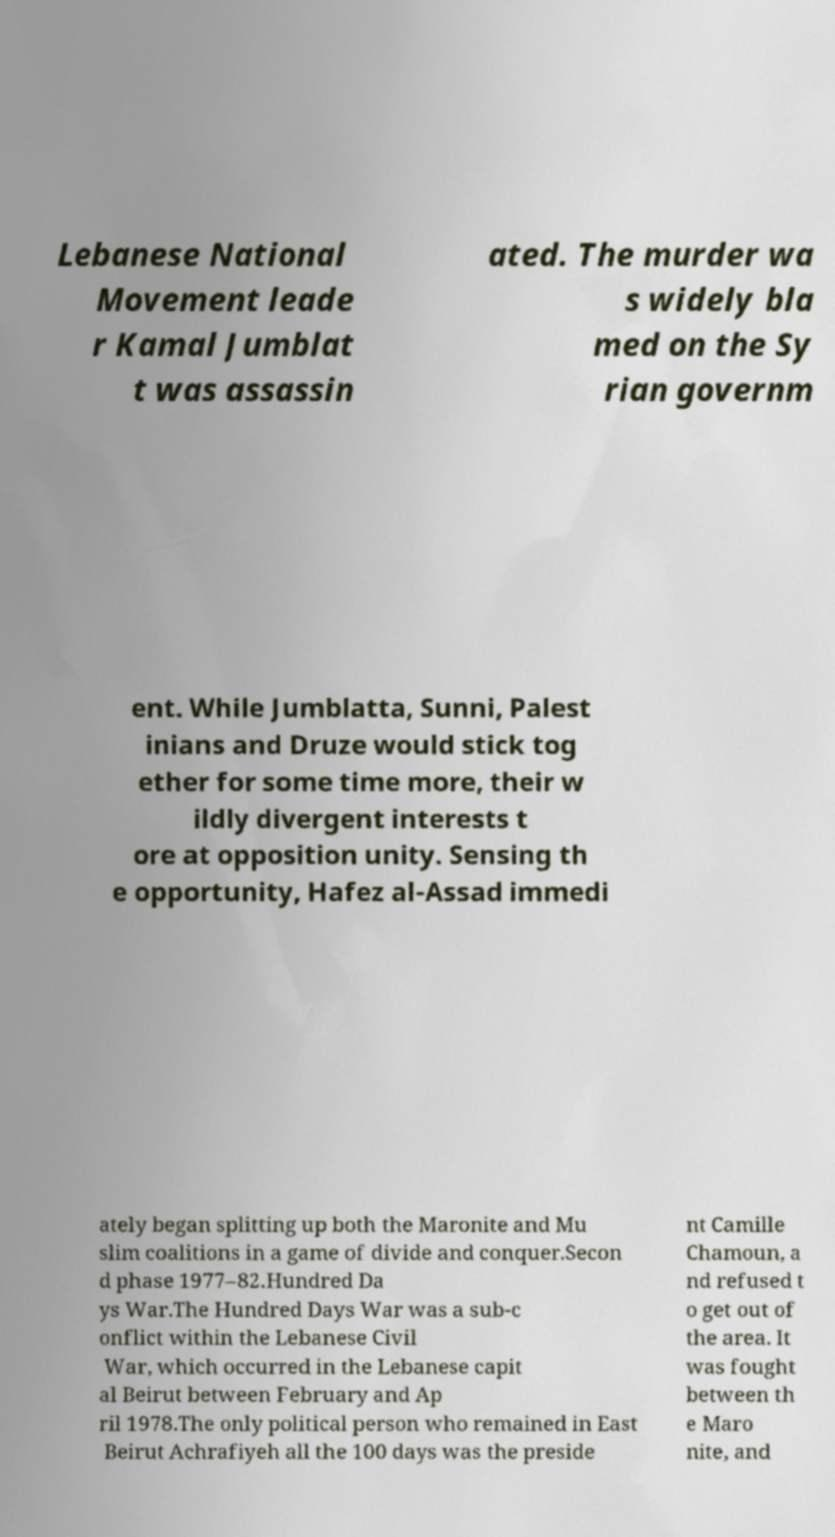Can you accurately transcribe the text from the provided image for me? Lebanese National Movement leade r Kamal Jumblat t was assassin ated. The murder wa s widely bla med on the Sy rian governm ent. While Jumblatta, Sunni, Palest inians and Druze would stick tog ether for some time more, their w ildly divergent interests t ore at opposition unity. Sensing th e opportunity, Hafez al-Assad immedi ately began splitting up both the Maronite and Mu slim coalitions in a game of divide and conquer.Secon d phase 1977–82.Hundred Da ys War.The Hundred Days War was a sub-c onflict within the Lebanese Civil War, which occurred in the Lebanese capit al Beirut between February and Ap ril 1978.The only political person who remained in East Beirut Achrafiyeh all the 100 days was the preside nt Camille Chamoun, a nd refused t o get out of the area. It was fought between th e Maro nite, and 